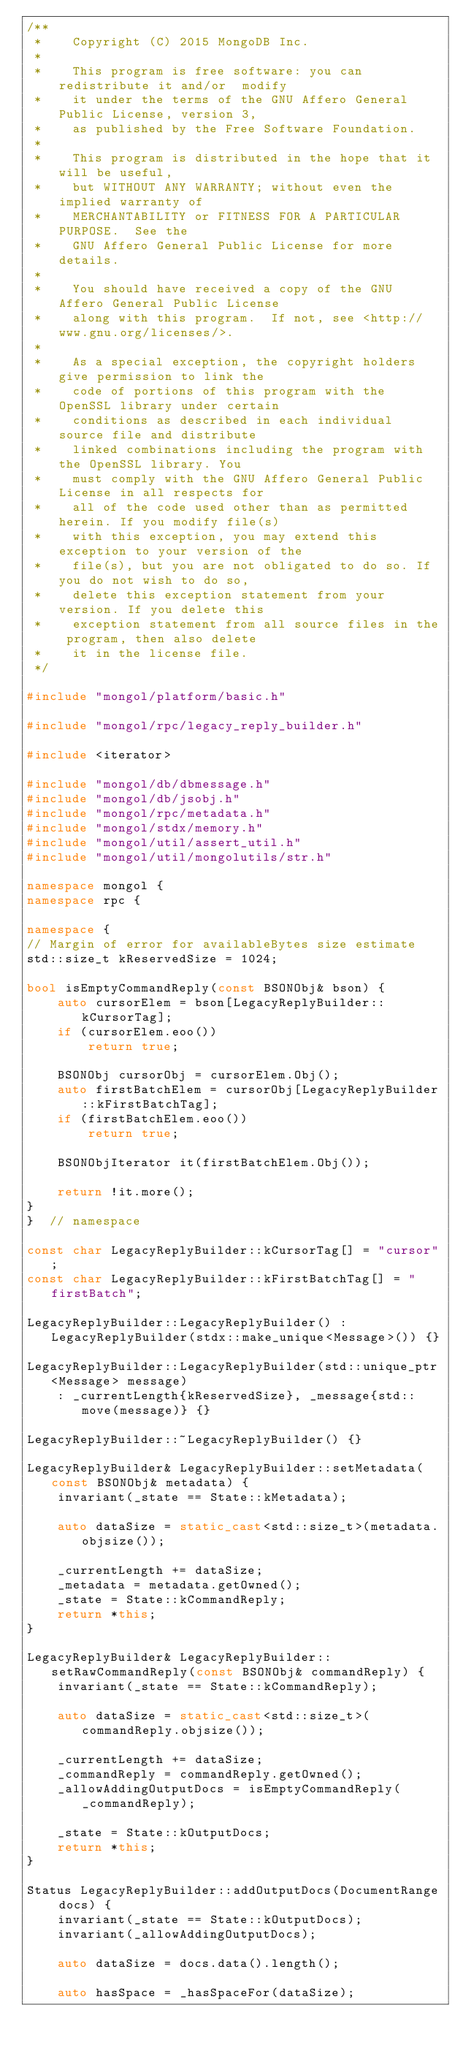Convert code to text. <code><loc_0><loc_0><loc_500><loc_500><_C++_>/**
 *    Copyright (C) 2015 MongoDB Inc.
 *
 *    This program is free software: you can redistribute it and/or  modify
 *    it under the terms of the GNU Affero General Public License, version 3,
 *    as published by the Free Software Foundation.
 *
 *    This program is distributed in the hope that it will be useful,
 *    but WITHOUT ANY WARRANTY; without even the implied warranty of
 *    MERCHANTABILITY or FITNESS FOR A PARTICULAR PURPOSE.  See the
 *    GNU Affero General Public License for more details.
 *
 *    You should have received a copy of the GNU Affero General Public License
 *    along with this program.  If not, see <http://www.gnu.org/licenses/>.
 *
 *    As a special exception, the copyright holders give permission to link the
 *    code of portions of this program with the OpenSSL library under certain
 *    conditions as described in each individual source file and distribute
 *    linked combinations including the program with the OpenSSL library. You
 *    must comply with the GNU Affero General Public License in all respects for
 *    all of the code used other than as permitted herein. If you modify file(s)
 *    with this exception, you may extend this exception to your version of the
 *    file(s), but you are not obligated to do so. If you do not wish to do so,
 *    delete this exception statement from your version. If you delete this
 *    exception statement from all source files in the program, then also delete
 *    it in the license file.
 */

#include "mongol/platform/basic.h"

#include "mongol/rpc/legacy_reply_builder.h"

#include <iterator>

#include "mongol/db/dbmessage.h"
#include "mongol/db/jsobj.h"
#include "mongol/rpc/metadata.h"
#include "mongol/stdx/memory.h"
#include "mongol/util/assert_util.h"
#include "mongol/util/mongolutils/str.h"

namespace mongol {
namespace rpc {

namespace {
// Margin of error for availableBytes size estimate
std::size_t kReservedSize = 1024;

bool isEmptyCommandReply(const BSONObj& bson) {
    auto cursorElem = bson[LegacyReplyBuilder::kCursorTag];
    if (cursorElem.eoo())
        return true;

    BSONObj cursorObj = cursorElem.Obj();
    auto firstBatchElem = cursorObj[LegacyReplyBuilder::kFirstBatchTag];
    if (firstBatchElem.eoo())
        return true;

    BSONObjIterator it(firstBatchElem.Obj());

    return !it.more();
}
}  // namespace

const char LegacyReplyBuilder::kCursorTag[] = "cursor";
const char LegacyReplyBuilder::kFirstBatchTag[] = "firstBatch";

LegacyReplyBuilder::LegacyReplyBuilder() : LegacyReplyBuilder(stdx::make_unique<Message>()) {}

LegacyReplyBuilder::LegacyReplyBuilder(std::unique_ptr<Message> message)
    : _currentLength{kReservedSize}, _message{std::move(message)} {}

LegacyReplyBuilder::~LegacyReplyBuilder() {}

LegacyReplyBuilder& LegacyReplyBuilder::setMetadata(const BSONObj& metadata) {
    invariant(_state == State::kMetadata);

    auto dataSize = static_cast<std::size_t>(metadata.objsize());

    _currentLength += dataSize;
    _metadata = metadata.getOwned();
    _state = State::kCommandReply;
    return *this;
}

LegacyReplyBuilder& LegacyReplyBuilder::setRawCommandReply(const BSONObj& commandReply) {
    invariant(_state == State::kCommandReply);

    auto dataSize = static_cast<std::size_t>(commandReply.objsize());

    _currentLength += dataSize;
    _commandReply = commandReply.getOwned();
    _allowAddingOutputDocs = isEmptyCommandReply(_commandReply);

    _state = State::kOutputDocs;
    return *this;
}

Status LegacyReplyBuilder::addOutputDocs(DocumentRange docs) {
    invariant(_state == State::kOutputDocs);
    invariant(_allowAddingOutputDocs);

    auto dataSize = docs.data().length();

    auto hasSpace = _hasSpaceFor(dataSize);</code> 